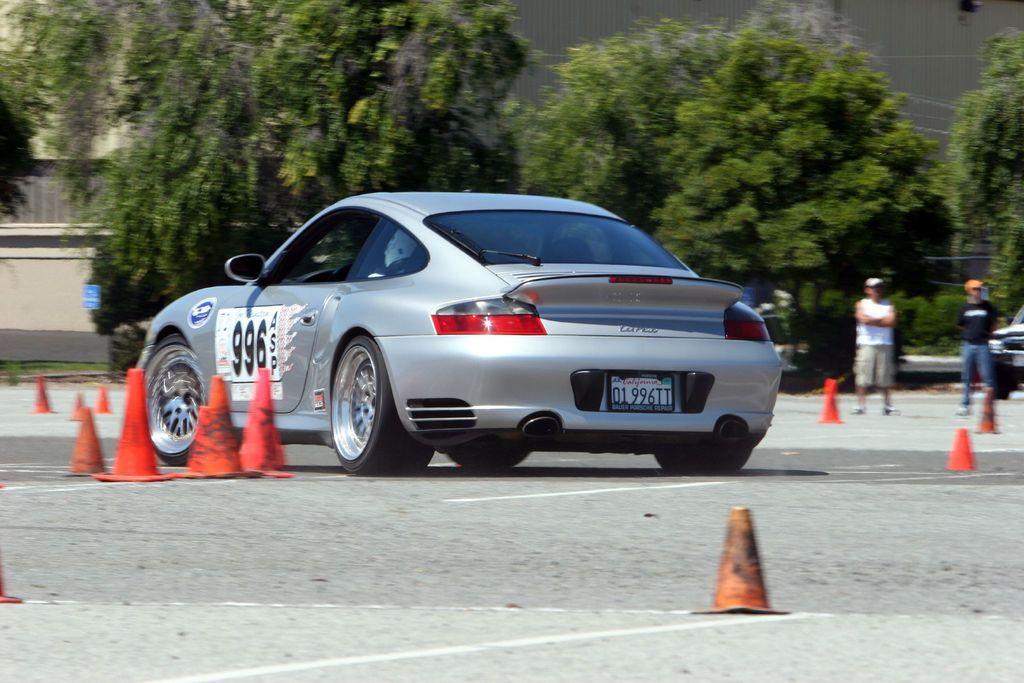Please provide a concise description of this image. In this picture I can see there is a car moving on the road and there are few traffic cones and there are two persons standing at the right side. There is a building on the left side and there are trees in the backdrop. 